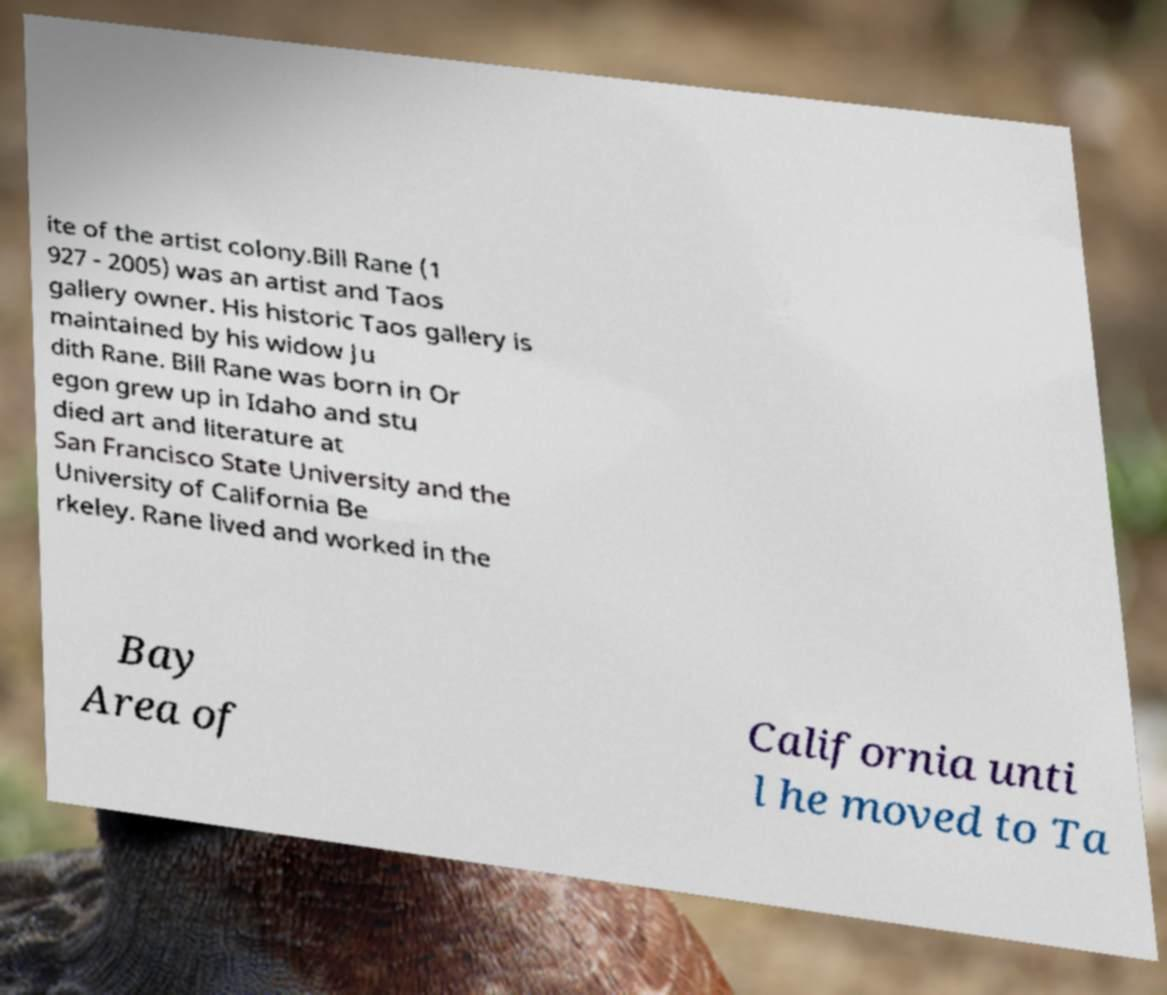I need the written content from this picture converted into text. Can you do that? ite of the artist colony.Bill Rane (1 927 - 2005) was an artist and Taos gallery owner. His historic Taos gallery is maintained by his widow Ju dith Rane. Bill Rane was born in Or egon grew up in Idaho and stu died art and literature at San Francisco State University and the University of California Be rkeley. Rane lived and worked in the Bay Area of California unti l he moved to Ta 